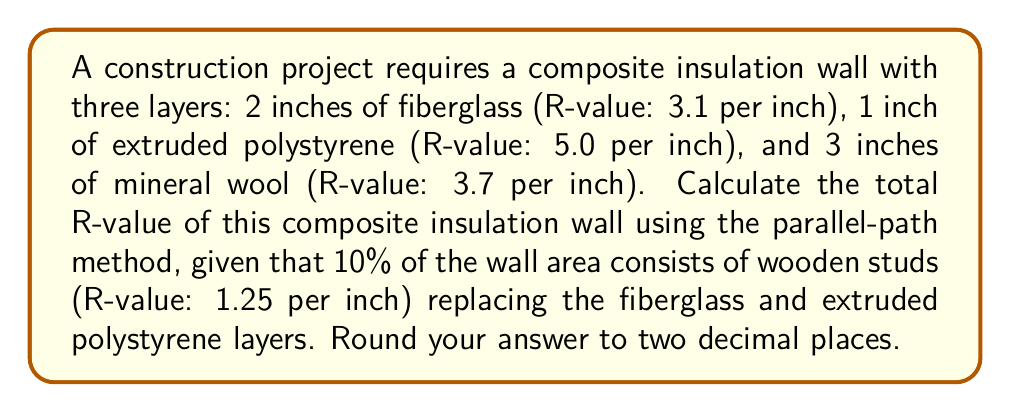Can you answer this question? To solve this problem, we'll follow these steps:

1) Calculate the R-value for the main insulation path:
   a) Fiberglass: $R_f = 2 \text{ in} \times 3.1 /\text{in} = 6.2$
   b) Extruded polystyrene: $R_x = 1 \text{ in} \times 5.0 /\text{in} = 5.0$
   c) Mineral wool: $R_m = 3 \text{ in} \times 3.7 /\text{in} = 11.1$
   Total for main path: $R_1 = 6.2 + 5.0 + 11.1 = 22.3$

2) Calculate the R-value for the stud path:
   a) Wood studs: $R_w = (2+1) \text{ in} \times 1.25 /\text{in} = 3.75$
   b) Mineral wool: $R_m = 11.1$ (same as before)
   Total for stud path: $R_2 = 3.75 + 11.1 = 14.85$

3) Use the parallel-path method to calculate the overall R-value:
   Let $f_1 = 0.9$ (fraction of main path) and $f_2 = 0.1$ (fraction of stud path)
   
   $$\frac{1}{R_{total}} = \frac{f_1}{R_1} + \frac{f_2}{R_2}$$
   
   $$\frac{1}{R_{total}} = \frac{0.9}{22.3} + \frac{0.1}{14.85}$$
   
   $$\frac{1}{R_{total}} = 0.04037 + 0.00673 = 0.0471$$
   
   $$R_{total} = \frac{1}{0.0471} = 21.23$$

4) Rounding to two decimal places: $R_{total} = 21.23$
Answer: $21.23$ 